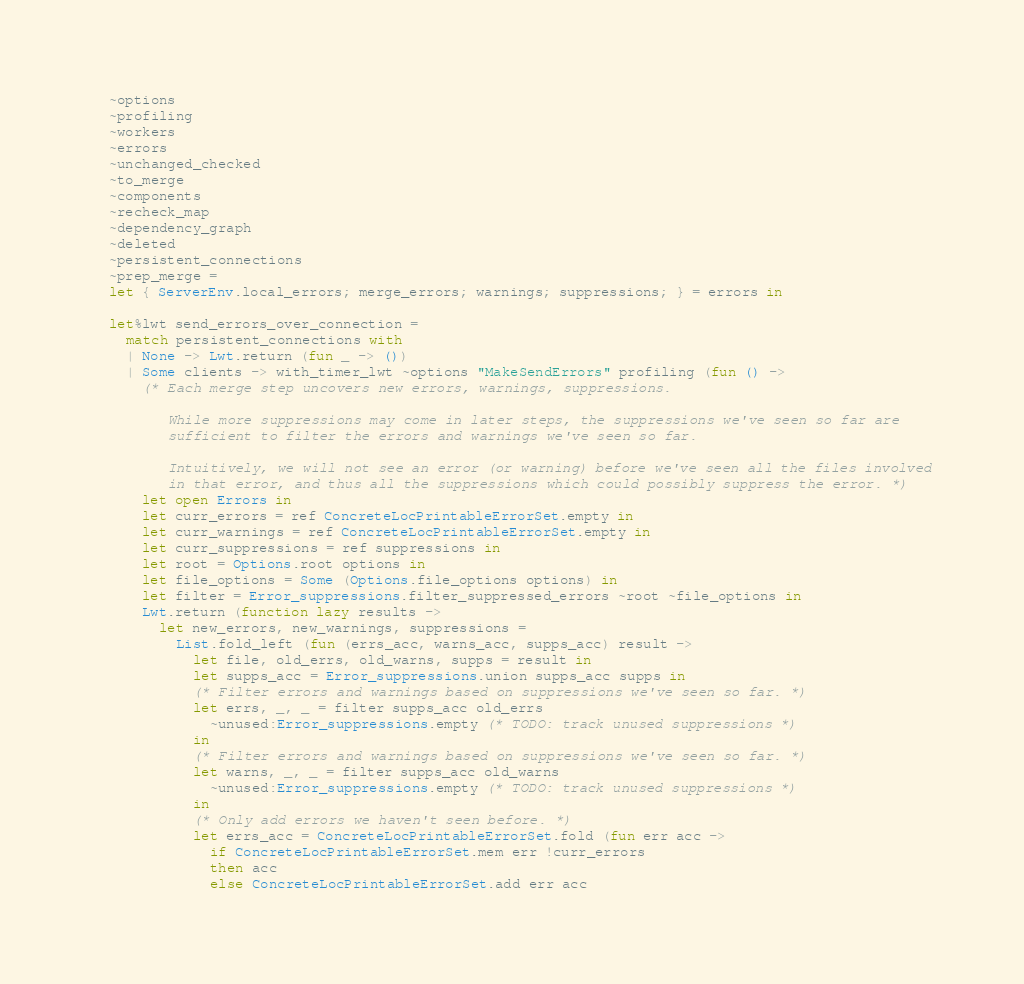Convert code to text. <code><loc_0><loc_0><loc_500><loc_500><_OCaml_>  ~options
  ~profiling
  ~workers
  ~errors
  ~unchanged_checked
  ~to_merge
  ~components
  ~recheck_map
  ~dependency_graph
  ~deleted
  ~persistent_connections
  ~prep_merge =
  let { ServerEnv.local_errors; merge_errors; warnings; suppressions; } = errors in

  let%lwt send_errors_over_connection =
    match persistent_connections with
    | None -> Lwt.return (fun _ -> ())
    | Some clients -> with_timer_lwt ~options "MakeSendErrors" profiling (fun () ->
      (* Each merge step uncovers new errors, warnings, suppressions.

         While more suppressions may come in later steps, the suppressions we've seen so far are
         sufficient to filter the errors and warnings we've seen so far.

         Intuitively, we will not see an error (or warning) before we've seen all the files involved
         in that error, and thus all the suppressions which could possibly suppress the error. *)
      let open Errors in
      let curr_errors = ref ConcreteLocPrintableErrorSet.empty in
      let curr_warnings = ref ConcreteLocPrintableErrorSet.empty in
      let curr_suppressions = ref suppressions in
      let root = Options.root options in
      let file_options = Some (Options.file_options options) in
      let filter = Error_suppressions.filter_suppressed_errors ~root ~file_options in
      Lwt.return (function lazy results ->
        let new_errors, new_warnings, suppressions =
          List.fold_left (fun (errs_acc, warns_acc, supps_acc) result ->
            let file, old_errs, old_warns, supps = result in
            let supps_acc = Error_suppressions.union supps_acc supps in
            (* Filter errors and warnings based on suppressions we've seen so far. *)
            let errs, _, _ = filter supps_acc old_errs
              ~unused:Error_suppressions.empty (* TODO: track unused suppressions *)
            in
            (* Filter errors and warnings based on suppressions we've seen so far. *)
            let warns, _, _ = filter supps_acc old_warns
              ~unused:Error_suppressions.empty (* TODO: track unused suppressions *)
            in
            (* Only add errors we haven't seen before. *)
            let errs_acc = ConcreteLocPrintableErrorSet.fold (fun err acc ->
              if ConcreteLocPrintableErrorSet.mem err !curr_errors
              then acc
              else ConcreteLocPrintableErrorSet.add err acc</code> 